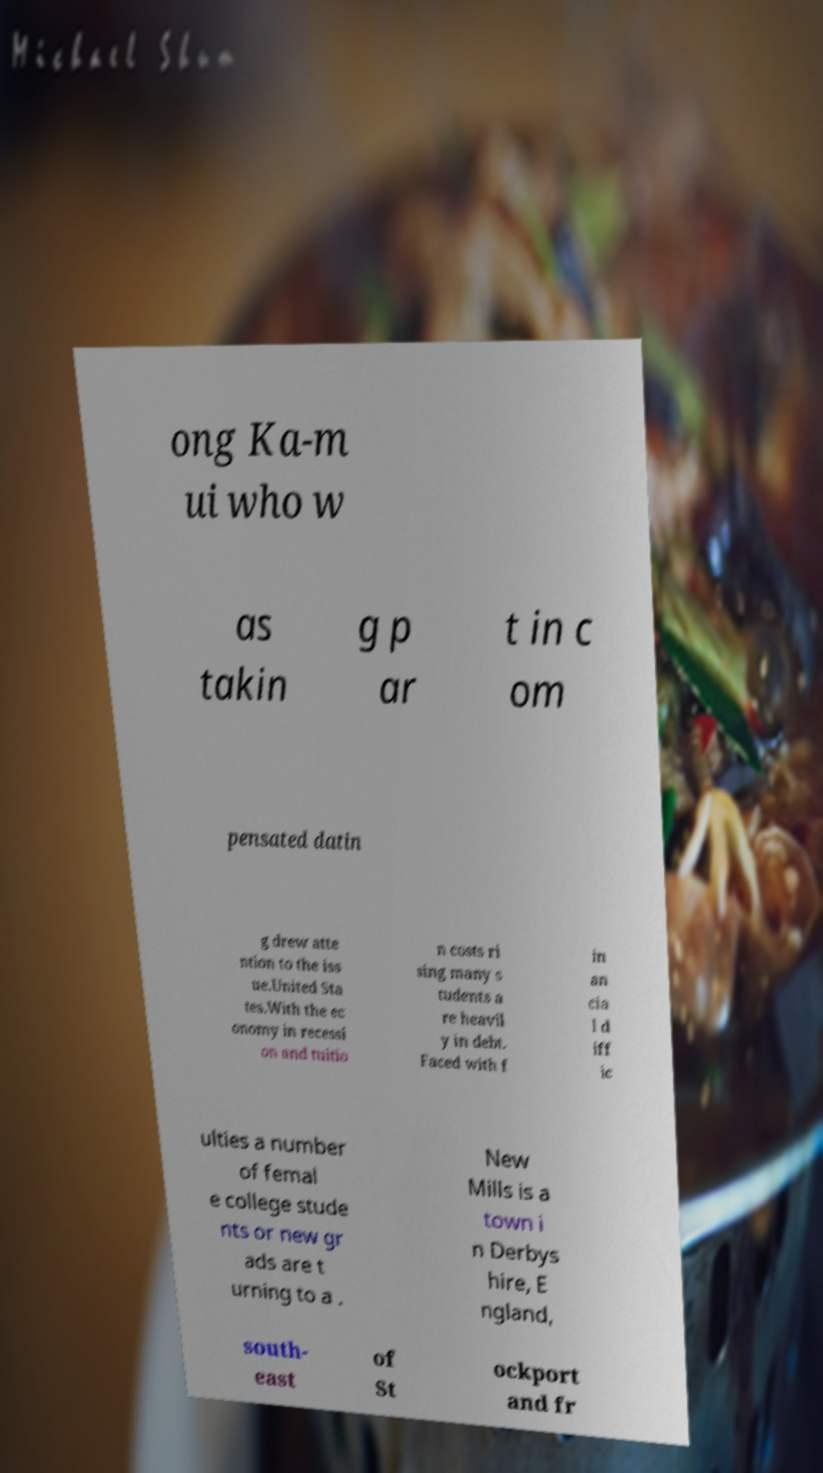Can you accurately transcribe the text from the provided image for me? ong Ka-m ui who w as takin g p ar t in c om pensated datin g drew atte ntion to the iss ue.United Sta tes.With the ec onomy in recessi on and tuitio n costs ri sing many s tudents a re heavil y in debt. Faced with f in an cia l d iff ic ulties a number of femal e college stude nts or new gr ads are t urning to a . New Mills is a town i n Derbys hire, E ngland, south- east of St ockport and fr 